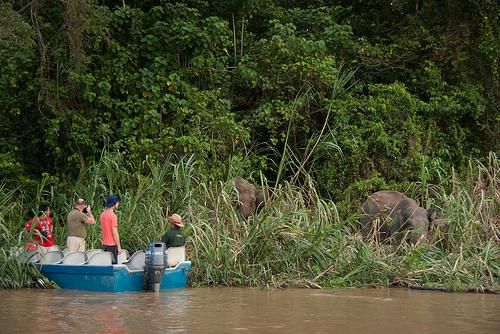Question: how many people are shown?
Choices:
A. Four.
B. Five.
C. Six.
D. Seven.
Answer with the letter. Answer: A Question: what are the people looking at?
Choices:
A. Elephants.
B. Giraffes.
C. Zebras.
D. Cows.
Answer with the letter. Answer: A Question: what is the bald man doing?
Choices:
A. Reading a book.
B. Looking through a telescope.
C. Taking a picture.
D. Watching television.
Answer with the letter. Answer: C Question: how does the water look?
Choices:
A. Muddy.
B. Clear.
C. Hazy.
D. Rocky.
Answer with the letter. Answer: A Question: where are they?
Choices:
A. In a car.
B. On a train.
C. On a plane.
D. In a boat.
Answer with the letter. Answer: D 